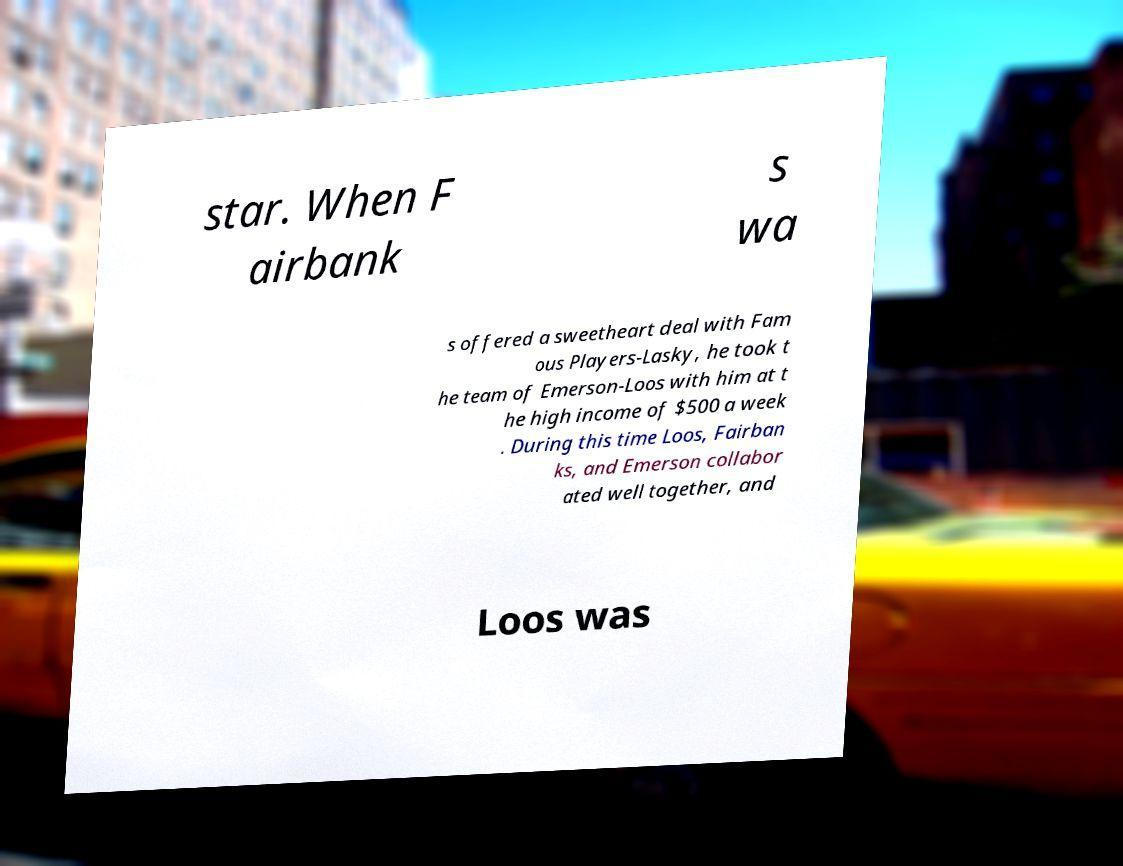Can you accurately transcribe the text from the provided image for me? star. When F airbank s wa s offered a sweetheart deal with Fam ous Players-Lasky, he took t he team of Emerson-Loos with him at t he high income of $500 a week . During this time Loos, Fairban ks, and Emerson collabor ated well together, and Loos was 